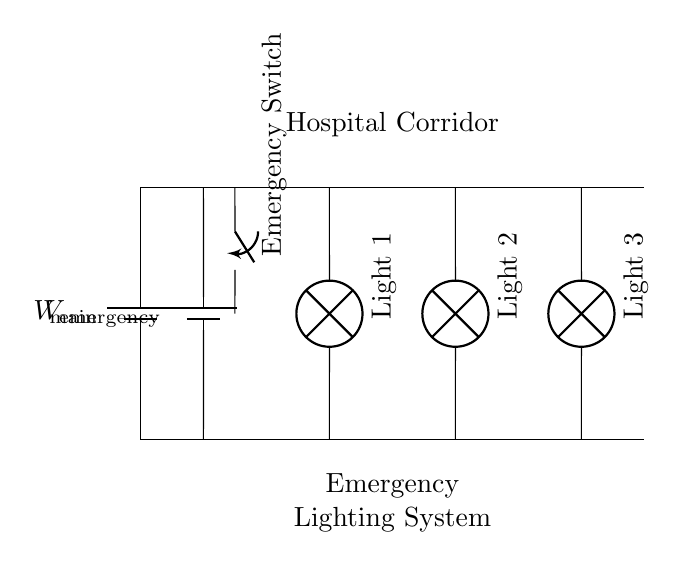What is the main power supply voltage? The main power supply is represented by the battery labeled as "V_main" in the circuit. Since the specific voltage value is not given in the diagram, we denote it as "V_main".
Answer: V_main How many lights are in the circuit? The circuit diagram shows three lamps labeled as "Light 1", "Light 2", and "Light 3". Therefore, the total number of lights can be counted directly based on the visual representation.
Answer: 3 What component ensures the system can switch to emergency power? The component that allows switching to emergency power is the "Emergency Switch" shown in the circuit. It connects to the emergency battery labeled "V_emergency" when activated.
Answer: Emergency Switch Are the lights connected in series or parallel? The lights are connected to the same voltage source from both the main power supply and emergency source, and they have their own paths. This indicates a parallel connection.
Answer: Parallel What happens to the lights if one lamp fails? In a parallel circuit, if one lamp fails, the other lamps remain lit since they have independent paths to the power supply. This allows the circuit to continue functioning without interruption.
Answer: Remains lit What is the purpose of the emergency lighting system? The purpose of the emergency lighting system is to provide illumination during power outages or emergencies in the hospital corridor, ensuring safety and visibility.
Answer: Safety and visibility Which voltage source is used in case of normal operation? The voltage source used during normal operation is indicated by the main power supply, labeled as "V_main". When the normal system is functional, this source is primarily used for operational lighting.
Answer: V_main 